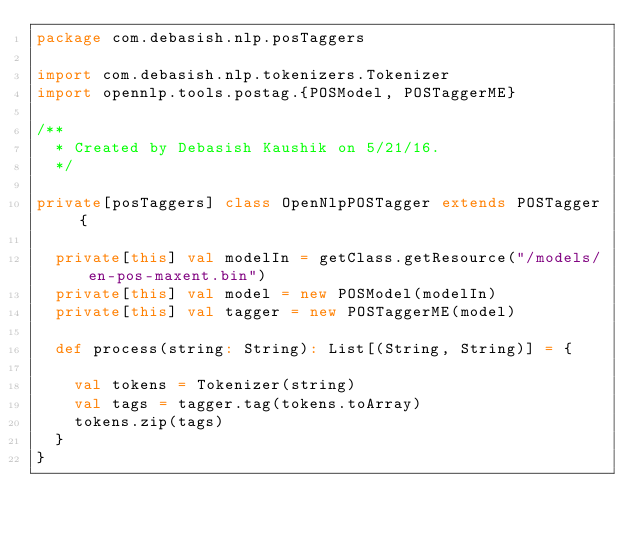<code> <loc_0><loc_0><loc_500><loc_500><_Scala_>package com.debasish.nlp.posTaggers

import com.debasish.nlp.tokenizers.Tokenizer
import opennlp.tools.postag.{POSModel, POSTaggerME}

/**
  * Created by Debasish Kaushik on 5/21/16.
  */

private[posTaggers] class OpenNlpPOSTagger extends POSTagger {

  private[this] val modelIn = getClass.getResource("/models/en-pos-maxent.bin")
  private[this] val model = new POSModel(modelIn)
  private[this] val tagger = new POSTaggerME(model)

  def process(string: String): List[(String, String)] = {

    val tokens = Tokenizer(string)
    val tags = tagger.tag(tokens.toArray)
    tokens.zip(tags)
  }
}</code> 